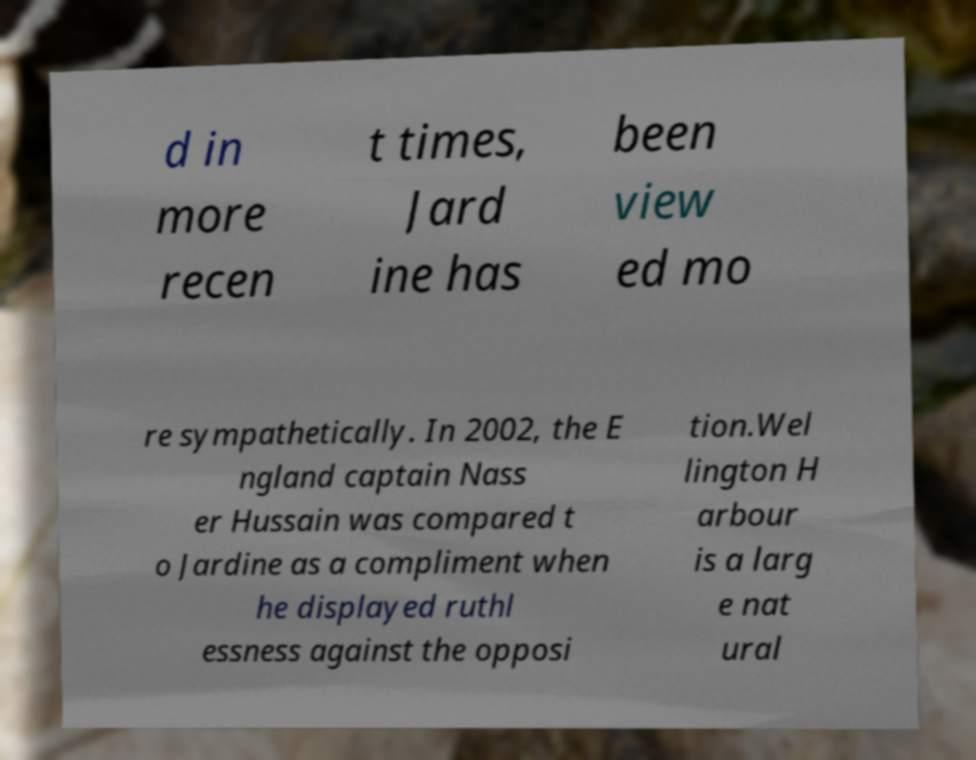Can you accurately transcribe the text from the provided image for me? d in more recen t times, Jard ine has been view ed mo re sympathetically. In 2002, the E ngland captain Nass er Hussain was compared t o Jardine as a compliment when he displayed ruthl essness against the opposi tion.Wel lington H arbour is a larg e nat ural 